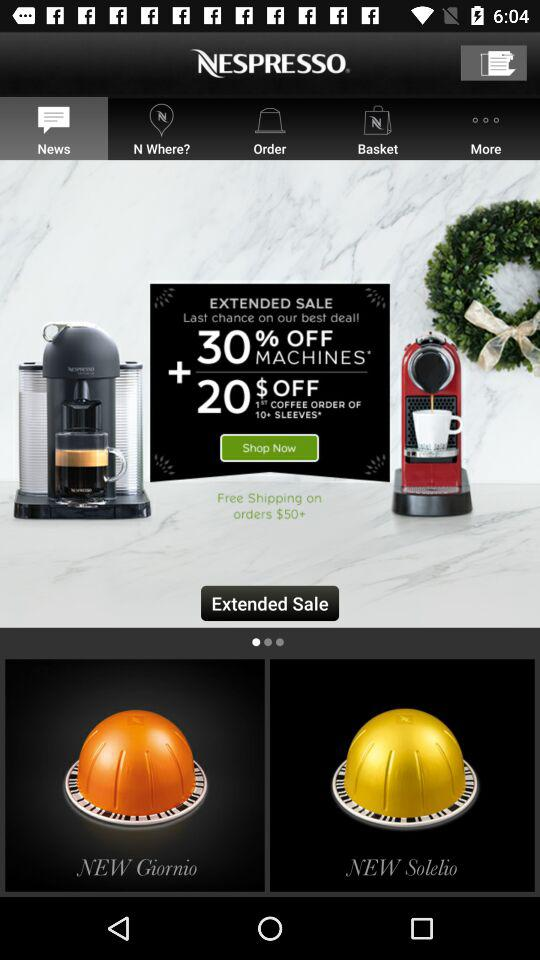How much did the last order cost?
When the provided information is insufficient, respond with <no answer>. <no answer> 